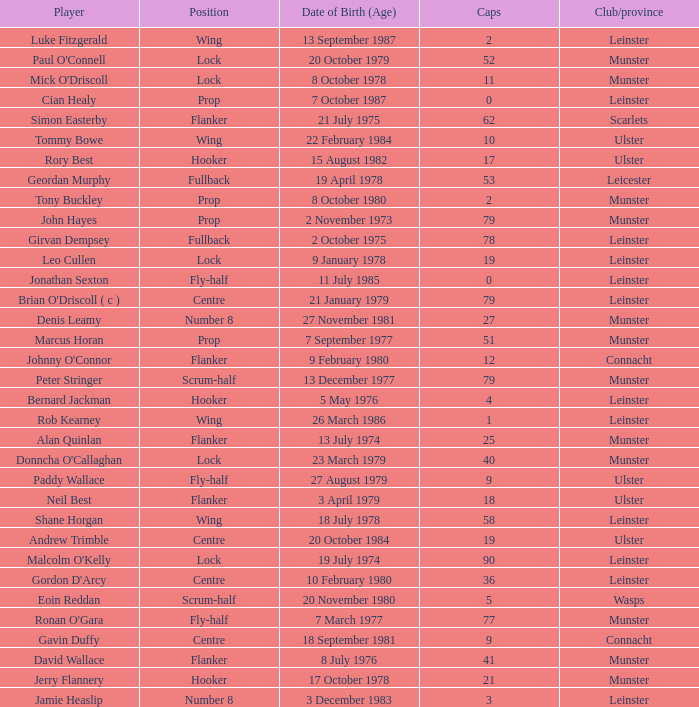Paddy Wallace who plays the position of fly-half has how many Caps? 9.0. 